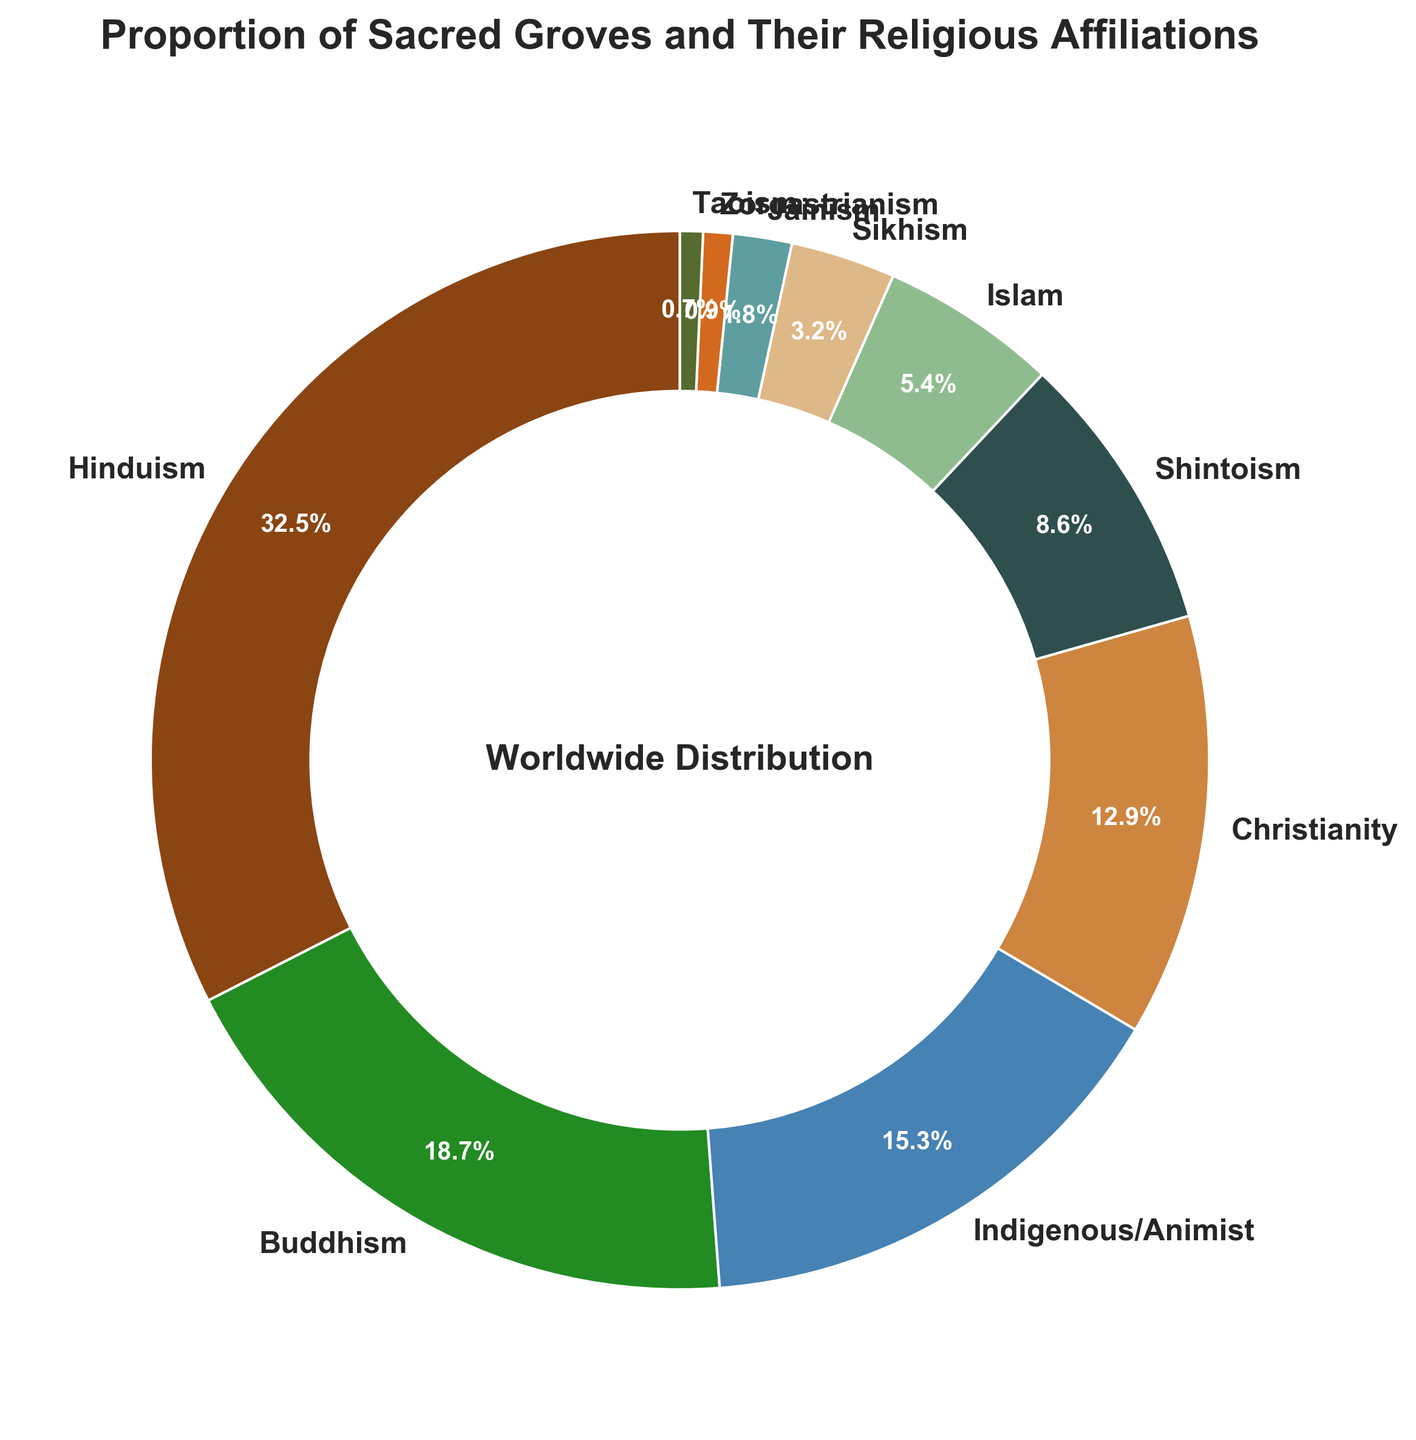What is the proportion of sacred groves affiliated with Christianity? Locate the slice that represents Christianity in the pie chart and read its label or autopct value, which shows the proportion percentage. This value is typically presented on or next to the pie section.
Answer: 12.9% Which religious affiliation has the largest proportion of sacred groves? Find the largest slice in the pie chart based on size and read its label to determine which religious affiliation has the highest percentage.
Answer: Hinduism Out of Buddhism, Shintoism, and Jainism, which has the smallest proportion of sacred groves? Compare the slices corresponding to Buddhism, Shintoism, and Jainism. Identify the smallest slice by observing the size or reading the percentage labels.
Answer: Jainism What is the combined proportion of sacred groves affiliated with Indigenous/Animist and Islam? Locate the slices representing Indigenous/Animist and Islam. Add their respective percentages together: 15.3% + 5.4%.
Answer: 20.7% Which religious affiliation has a proportion of sacred groves closest to 10%? Scan the pie chart slices for percentages near 10%. Identify the label which is closest to 10%.
Answer: Shintoism How does the proportion of sacred groves affiliated with Sikhism compare to that of Zoroastrianism? Compare the percentages indicated for Sikhism and Zoroastrianism, looking at their respective slices in the chart.
Answer: Sikhism > Zoroastrianism How many religious affiliations have a proportion of sacred groves less than 5%? Identify and count the slices that represent religious affiliations with percentages less than 5% by looking at their labels or autopct values.
Answer: 4 What is the difference in the proportion of sacred groves between Hinduism and Buddhism? Subtract the percentage of Buddhist sacred groves from that of Hindu sacred groves: 32.5% - 18.7%.
Answer: 13.8% Which color is used to represent Taoism in the pie chart? Match the label for Taoism to its corresponding pie slice and note its color.
Answer: Greenish-brown (or hex code simplified description) What is the total proportion of sacred groves associated with Buddhism, Christianity, and Shintoism combined? Sum the percentages of sacred groves for Buddhism, Christianity, and Shintoism: 18.7% + 12.9% + 8.6%.
Answer: 40.2% 